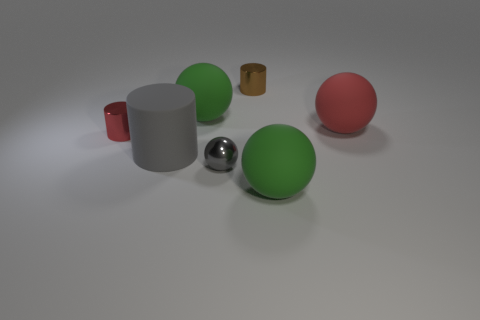What materials appear to be used for the objects in this image? The objects in the image seem to be made from different materials. The sphere that stands out with its reflective surface looks to be metallic, possibly steel, given its shine and reflection. The other solid-colored spheres and the cylinder appear matte and could be made of a plastic or rubber material, while the smaller objects resembling cups might be ceramic or metallic, judging by their respective luster and shape. 